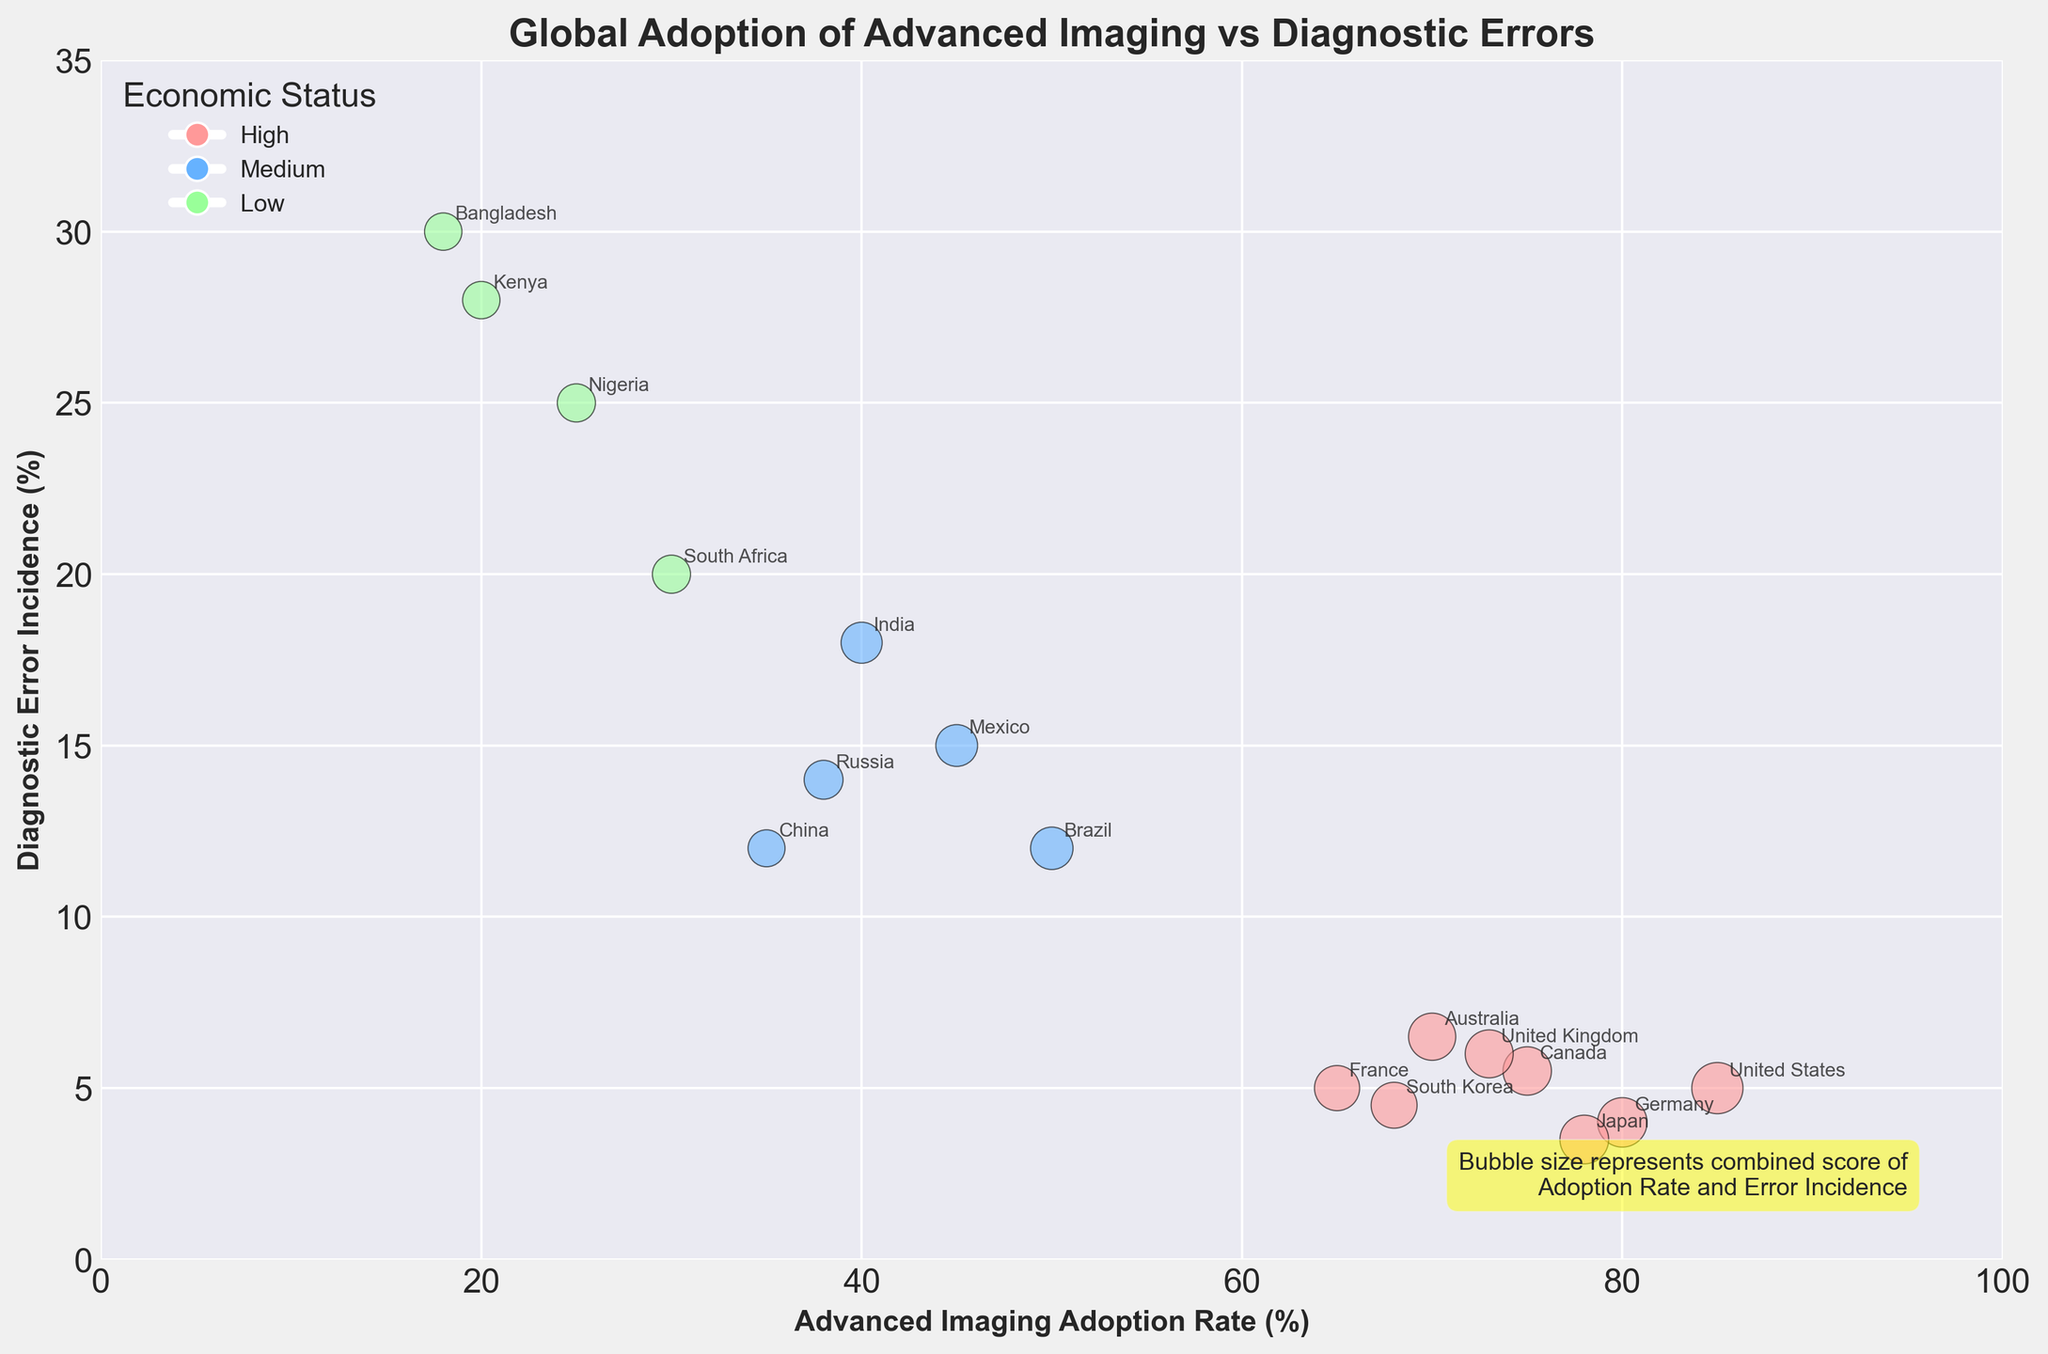What is the title of the figure? The title is usually displayed at the top of the figure. In this case, it reads 'Global Adoption of Advanced Imaging vs Diagnostic Errors'.
Answer: Global Adoption of Advanced Imaging vs Diagnostic Errors How many countries are represented in the dataset? Each bubble represents a country, and the country names are annotated next to the bubbles. By counting the names, there are 17 countries.
Answer: 17 Which country has the highest Advanced Imaging Adoption Rate, and what is the rate? The x-axis represents the Advanced Imaging Adoption Rate. The bubble farthest to the right has the highest rate. The country is the United States with a rate of 85%.
Answer: United States, 85% Which country has the highest Diagnostic Error Incidence, and what is the incidence rate? The y-axis represents the Diagnostic Error Incidence. The bubble highest up along the y-axis indicates the highest incidence. This country is Bangladesh with a rate of 30%.
Answer: Bangladesh, 30% What are the three economic statuses represented by different colors, and what color is associated with each? The legend on the plot shows the economic statuses and their respective colors. High is pink, Medium is blue, and Low is green.
Answer: High: pink, Medium: blue, Low: green What is the Diagnostic Error Incidence for South Korea? Locate the bubble annotated with 'South Korea'. The y-axis value corresponding to this bubble is the Diagnostic Error Incidence, which is 4.5%.
Answer: 4.5% Compare the bubble sizes of United States and China. Which one is larger and what does a larger bubble size indicate? Bubble sizes are defined by the combined score of Adoption Rate and Error Incidence. The bubble for the United States appears larger than China's, indicating a higher combined score.
Answer: United States What is the relationship between Advanced Imaging Adoption Rate and Diagnostic Error Incidence across the countries? As observed from the scatter plot, countries with higher Advanced Imaging Adoption Rates tend to have lower Diagnostic Error Incidences.
Answer: Inversely related Which country has the smallest bubble size and what are its Advanced Imaging Adoption Rate and Diagnostic Error Incidence? The smallest bubble identifies the country with the lowest combined score. This is Bangladesh with an adoption rate of 18% and an error incidence of 30%.
Answer: Bangladesh, 18%, 30% Identify two countries that have a similar Diagnostic Error Incidence but different Advanced Imaging Adoption Rates. France and United States both have a Diagnostic Error Incidence of 5%, but differing Advanced Imaging Adoption Rates (65% for France, 85% for United States).
Answer: France and United States What is the general trend of diagnostic errors in countries with a medium economic status? Observe the bubbles in blue color (representing medium status) and note their vertical positions. Generally, these countries have higher diagnostic error incidences relative to high economic status countries.
Answer: Higher diagnostic errors 